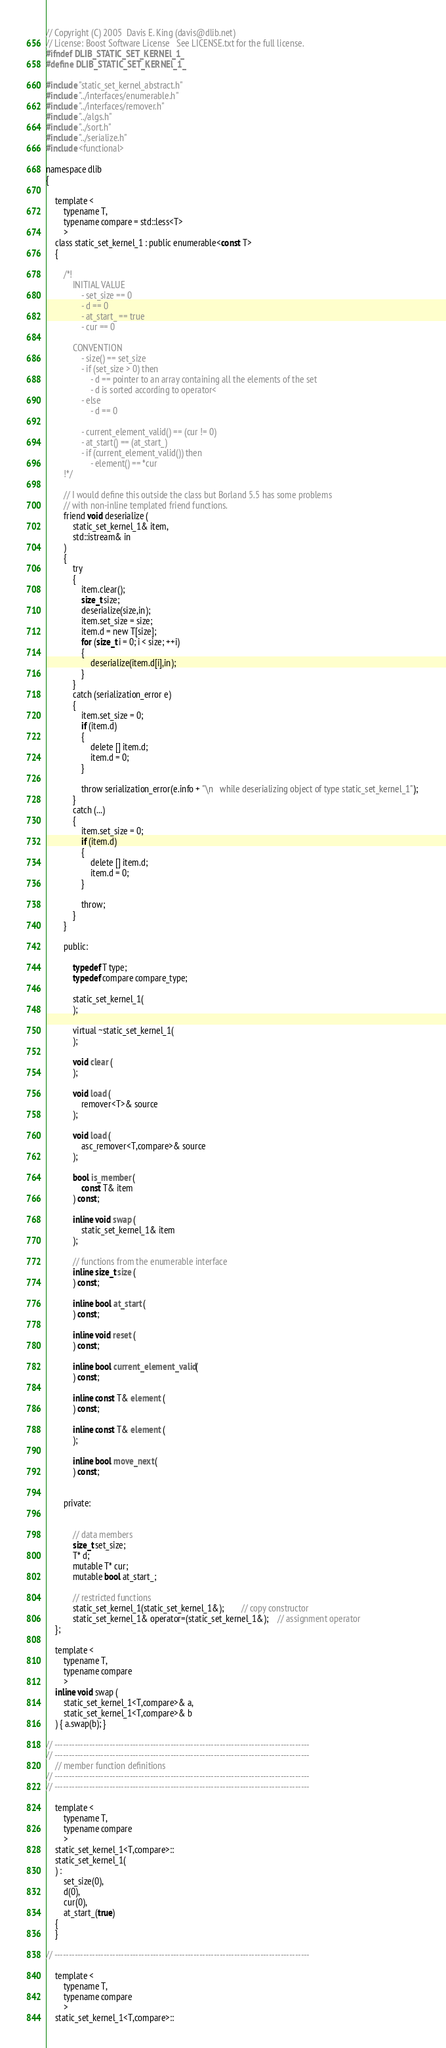<code> <loc_0><loc_0><loc_500><loc_500><_C_>// Copyright (C) 2005  Davis E. King (davis@dlib.net)
// License: Boost Software License   See LICENSE.txt for the full license.
#ifndef DLIB_STATIC_SET_KERNEl_1_
#define DLIB_STATIC_SET_KERNEl_1_

#include "static_set_kernel_abstract.h"
#include "../interfaces/enumerable.h"
#include "../interfaces/remover.h"
#include "../algs.h"
#include "../sort.h"
#include "../serialize.h"
#include <functional>

namespace dlib
{

    template <
        typename T,
        typename compare = std::less<T>
        >
    class static_set_kernel_1 : public enumerable<const T>
    {

        /*!
            INITIAL VALUE
                - set_size == 0
                - d == 0
                - at_start_ == true
                - cur == 0

            CONVENTION
                - size() == set_size
                - if (set_size > 0) then
                    - d == pointer to an array containing all the elements of the set                
                    - d is sorted according to operator<
                - else  
                    - d == 0

                - current_element_valid() == (cur != 0)
                - at_start() == (at_start_)
                - if (current_element_valid()) then
                    - element() == *cur
        !*/

        // I would define this outside the class but Borland 5.5 has some problems
        // with non-inline templated friend functions.
        friend void deserialize (
            static_set_kernel_1& item, 
            std::istream& in
        )    
        {
            try
            {
                item.clear();
                size_t size;
                deserialize(size,in);
                item.set_size = size;
                item.d = new T[size];
                for (size_t i = 0; i < size; ++i)
                {
                    deserialize(item.d[i],in);
                }
            }
            catch (serialization_error e)
            { 
                item.set_size = 0;
                if (item.d)
                {
                    delete [] item.d;
                    item.d = 0;
                }

                throw serialization_error(e.info + "\n   while deserializing object of type static_set_kernel_1"); 
            }
            catch (...)
            {
                item.set_size = 0;
                if (item.d)
                {
                    delete [] item.d;
                    item.d = 0;
                }

                throw;
            }
        } 

        public:

            typedef T type;
            typedef compare compare_type;

            static_set_kernel_1(
            );

            virtual ~static_set_kernel_1(
            ); 

            void clear (
            );

            void load (
                remover<T>& source
            );

            void load (
                asc_remover<T,compare>& source
            );

            bool is_member (
                const T& item
            ) const;

            inline void swap (
                static_set_kernel_1& item
            );
    
            // functions from the enumerable interface
            inline size_t size (
            ) const;

            inline bool at_start (
            ) const;

            inline void reset (
            ) const;

            inline bool current_element_valid (
            ) const;

            inline const T& element (
            ) const;

            inline const T& element (
            );

            inline bool move_next (
            ) const;


        private:

   
            // data members
            size_t set_size;
            T* d;
            mutable T* cur;
            mutable bool at_start_;

            // restricted functions
            static_set_kernel_1(static_set_kernel_1&);        // copy constructor
            static_set_kernel_1& operator=(static_set_kernel_1&);    // assignment operator
    };

    template <
        typename T,
        typename compare
        >
    inline void swap (
        static_set_kernel_1<T,compare>& a, 
        static_set_kernel_1<T,compare>& b 
    ) { a.swap(b); }   

// ----------------------------------------------------------------------------------------
// ----------------------------------------------------------------------------------------
    // member function definitions
// ----------------------------------------------------------------------------------------
// ----------------------------------------------------------------------------------------

    template <
        typename T,
        typename compare
        >
    static_set_kernel_1<T,compare>::
    static_set_kernel_1(
    ) :
        set_size(0),
        d(0),
        cur(0),
        at_start_(true)
    {
    }

// ----------------------------------------------------------------------------------------

    template <
        typename T,
        typename compare
        >
    static_set_kernel_1<T,compare>::</code> 